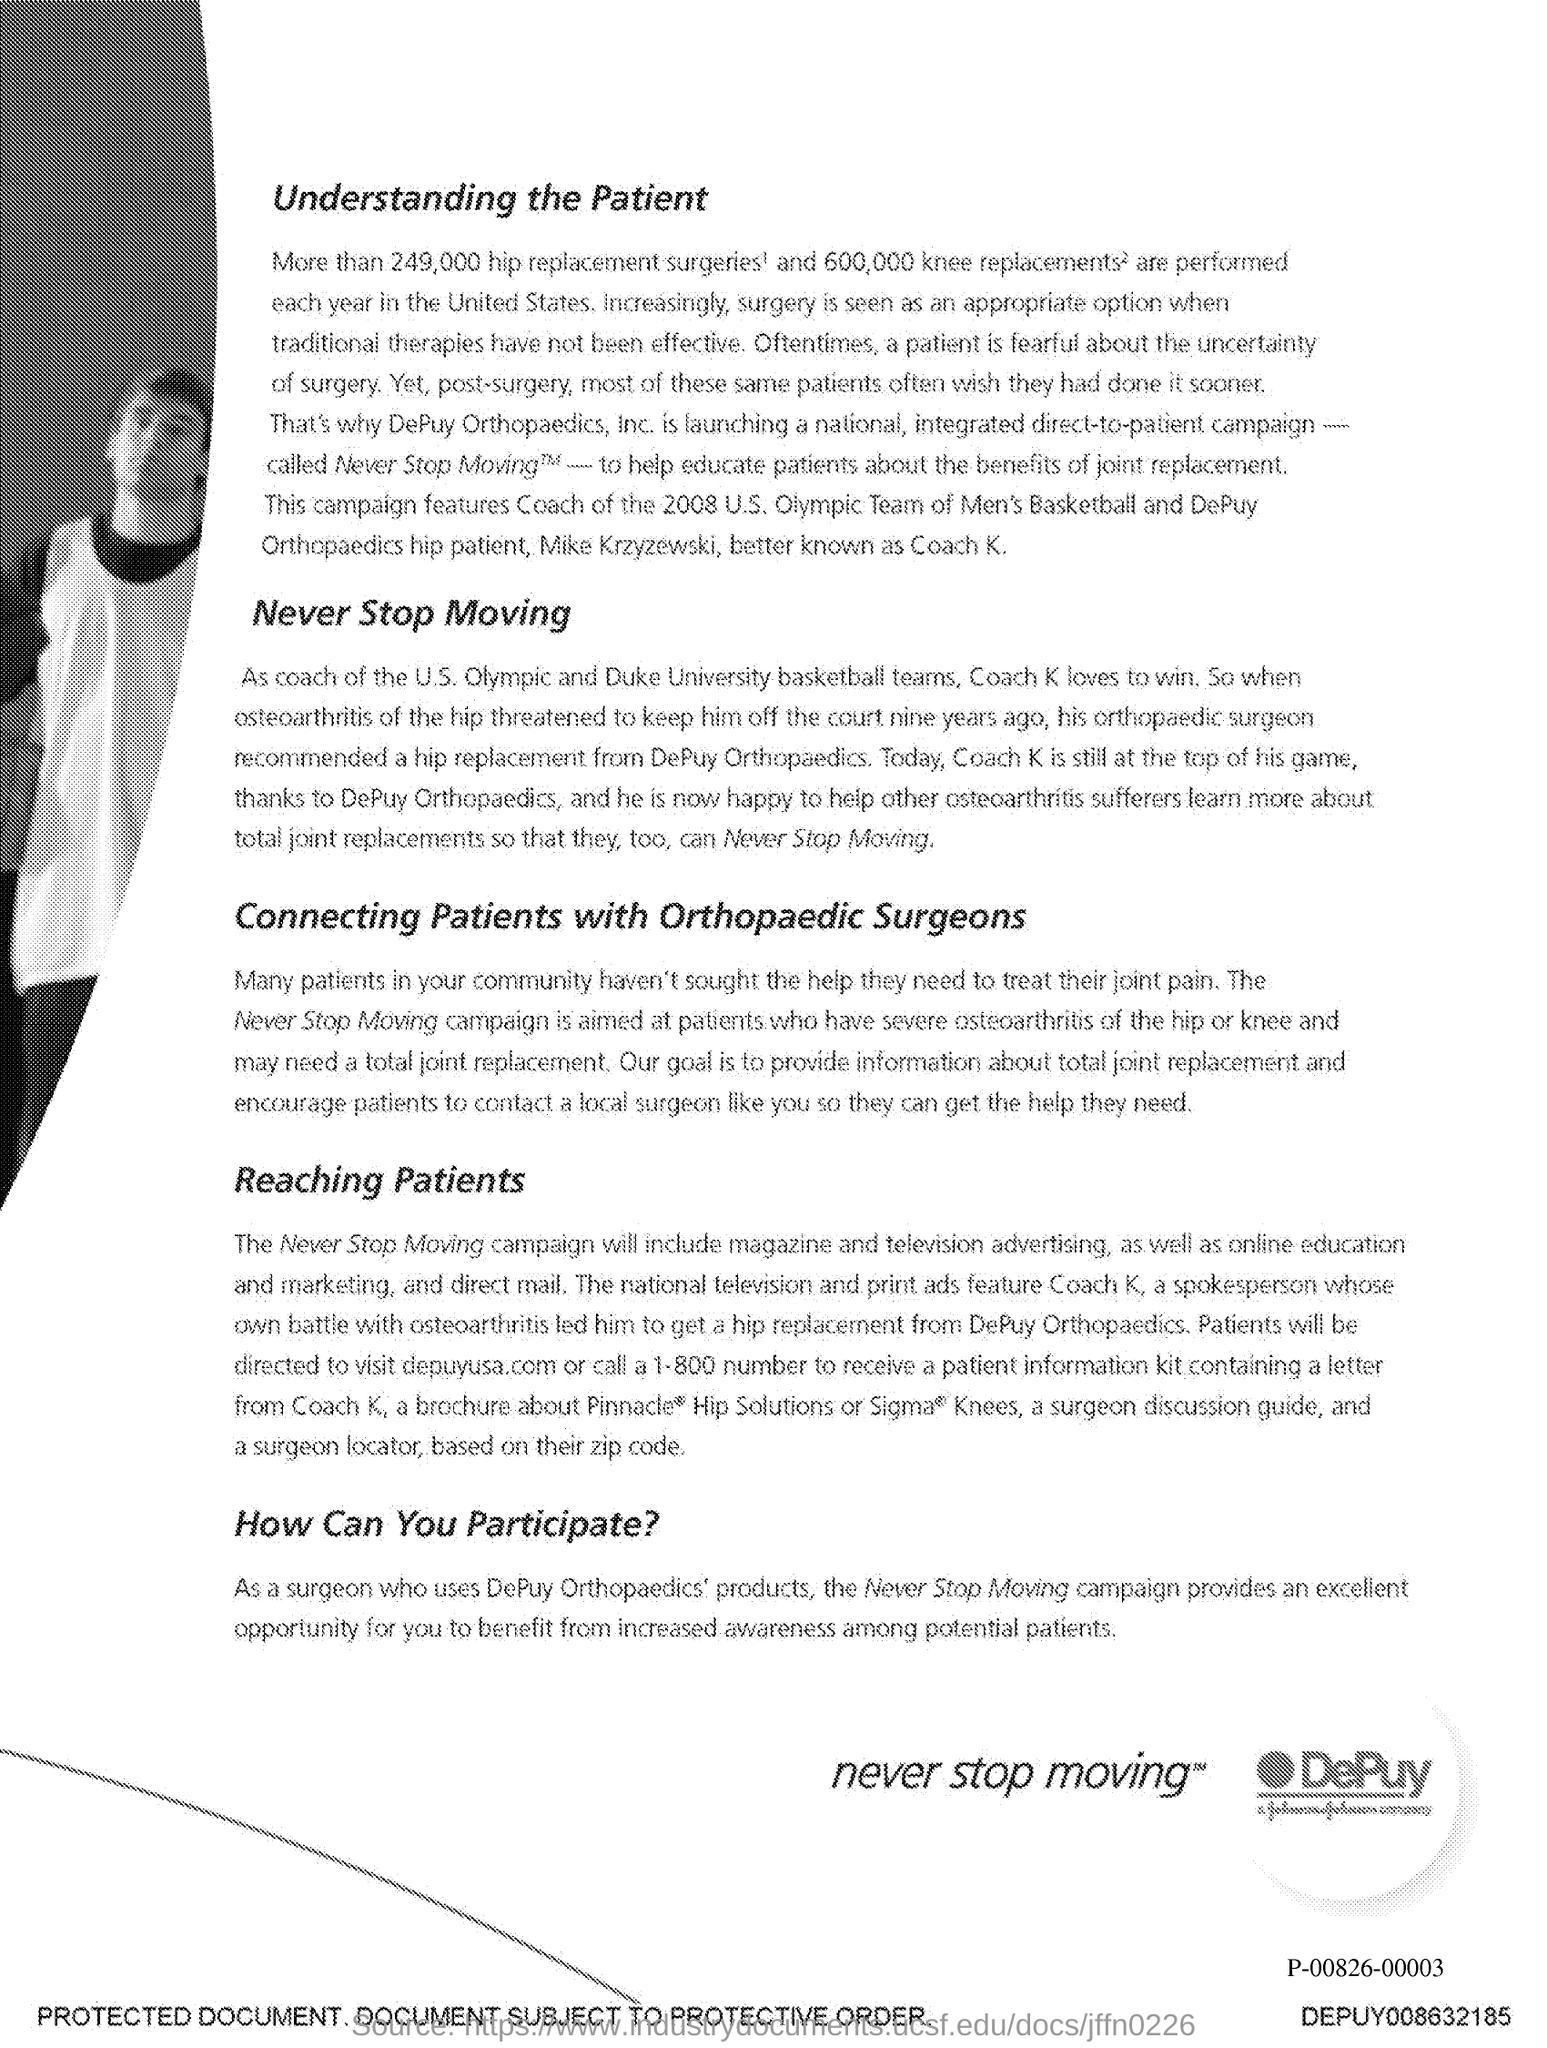What is the first title in the document?
Your answer should be compact. Understanding the patient. What is the second title in this document?
Your answer should be very brief. Never stop Moving. 